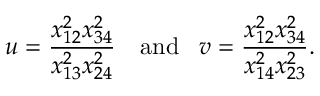<formula> <loc_0><loc_0><loc_500><loc_500>u = \frac { x _ { 1 2 } ^ { 2 } x _ { 3 4 } ^ { 2 } } { x _ { 1 3 } ^ { 2 } x _ { 2 4 } ^ { 2 } } \, a n d \, v = \frac { x _ { 1 2 } ^ { 2 } x _ { 3 4 } ^ { 2 } } { x _ { 1 4 } ^ { 2 } x _ { 2 3 } ^ { 2 } } .</formula> 